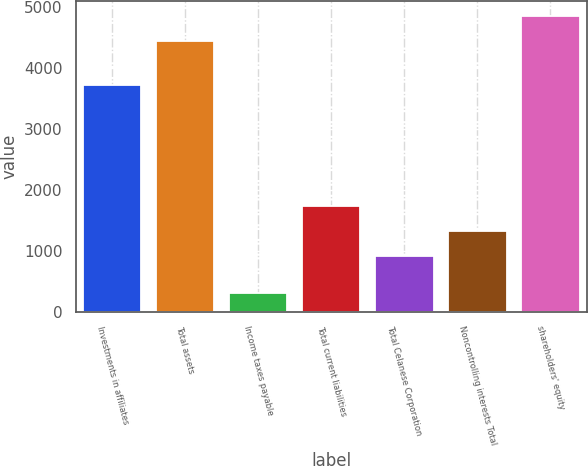<chart> <loc_0><loc_0><loc_500><loc_500><bar_chart><fcel>Investments in affiliates<fcel>Total assets<fcel>Income taxes payable<fcel>Total current liabilities<fcel>Total Celanese Corporation<fcel>Noncontrolling interests Total<fcel>shareholders' equity<nl><fcel>3721<fcel>4437<fcel>309<fcel>1728.6<fcel>903<fcel>1315.8<fcel>4849.8<nl></chart> 